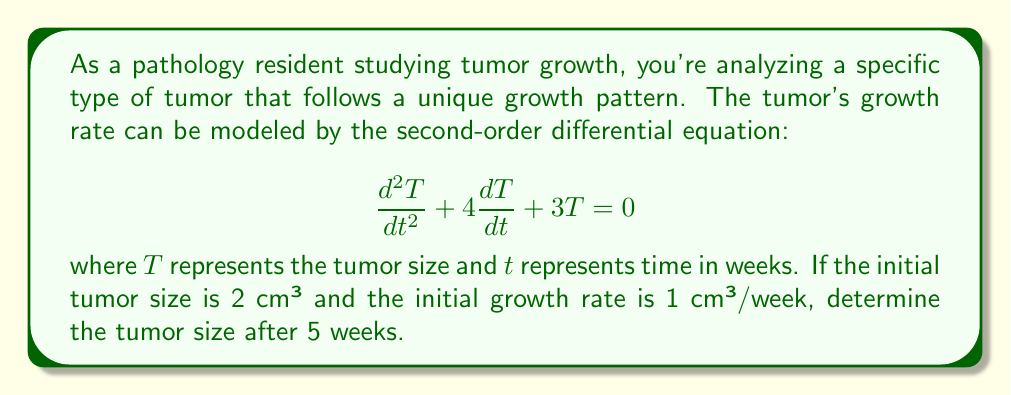Solve this math problem. To solve this problem, we need to follow these steps:

1) First, we need to find the general solution of the differential equation. The characteristic equation is:

   $$r^2 + 4r + 3 = 0$$

2) Solving this quadratic equation:
   $$(r + 1)(r + 3) = 0$$
   $$r = -1 \text{ or } r = -3$$

3) Therefore, the general solution is:

   $$T(t) = C_1e^{-t} + C_2e^{-3t}$$

4) Now, we use the initial conditions to find $C_1$ and $C_2$:

   At $t = 0$, $T(0) = 2$:
   $$2 = C_1 + C_2 \quad \text{(Equation 1)}$$

   Also, $\frac{dT}{dt}(0) = 1$:
   $$\frac{dT}{dt} = -C_1e^{-t} - 3C_2e^{-3t}$$
   $$1 = -C_1 - 3C_2 \quad \text{(Equation 2)}$$

5) Solving these simultaneous equations:
   From Equation 2: $C_1 = -1 - 3C_2$
   Substituting into Equation 1:
   $$2 = (-1 - 3C_2) + C_2$$
   $$2 = -1 - 2C_2$$
   $$C_2 = -\frac{3}{2}$$
   Therefore, $C_1 = \frac{7}{2}$

6) The particular solution is:

   $$T(t) = \frac{7}{2}e^{-t} - \frac{3}{2}e^{-3t}$$

7) To find the tumor size after 5 weeks, we substitute $t = 5$:

   $$T(5) = \frac{7}{2}e^{-5} - \frac{3}{2}e^{-15}$$

8) Calculating this value:

   $$T(5) \approx 0.0302 \text{ cm³}$$
Answer: The tumor size after 5 weeks is approximately 0.0302 cm³. 